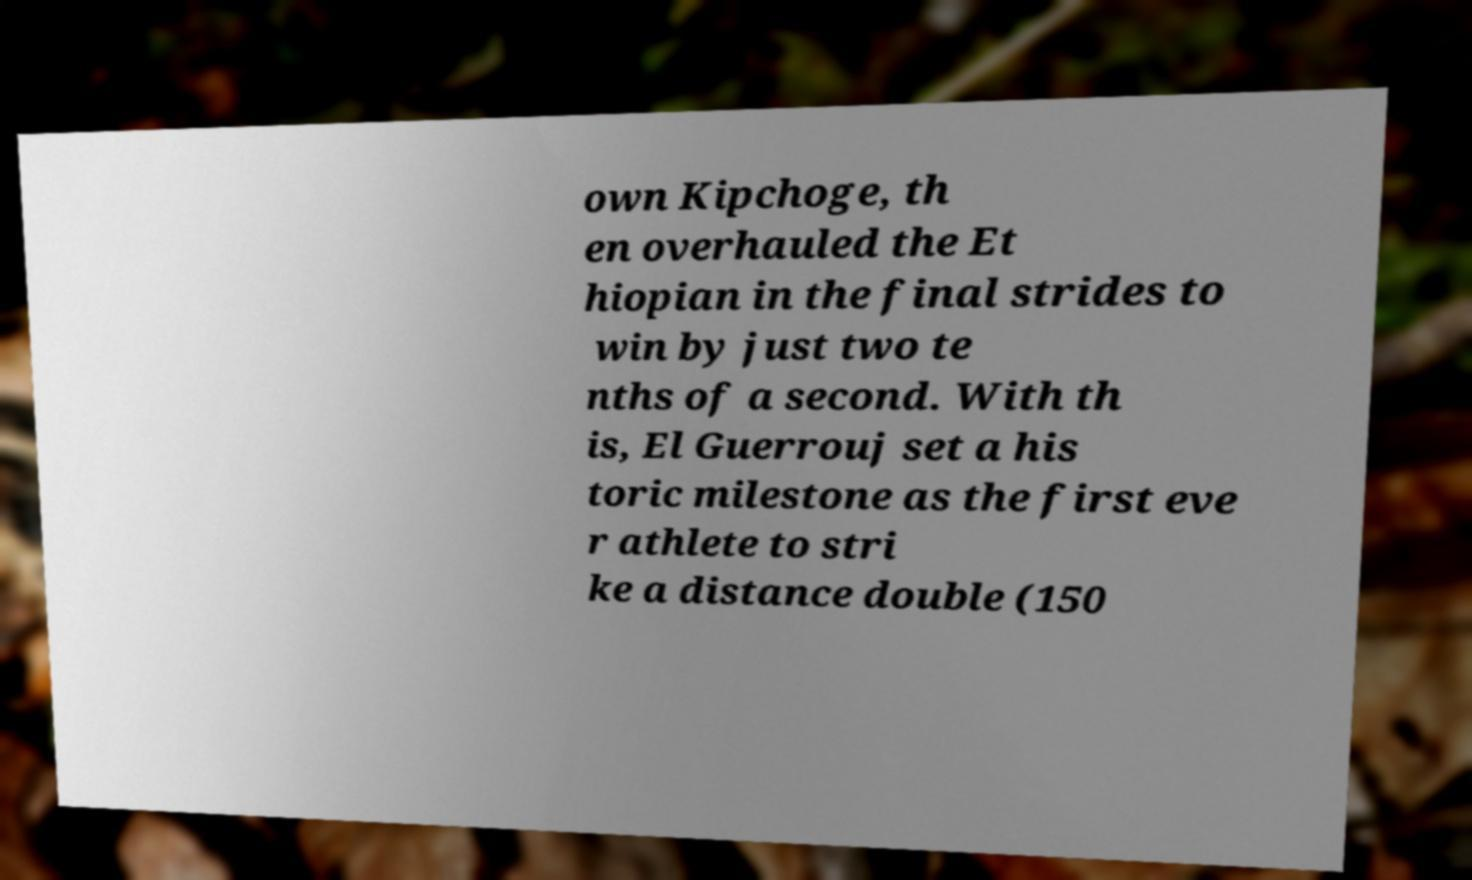Could you assist in decoding the text presented in this image and type it out clearly? own Kipchoge, th en overhauled the Et hiopian in the final strides to win by just two te nths of a second. With th is, El Guerrouj set a his toric milestone as the first eve r athlete to stri ke a distance double (150 